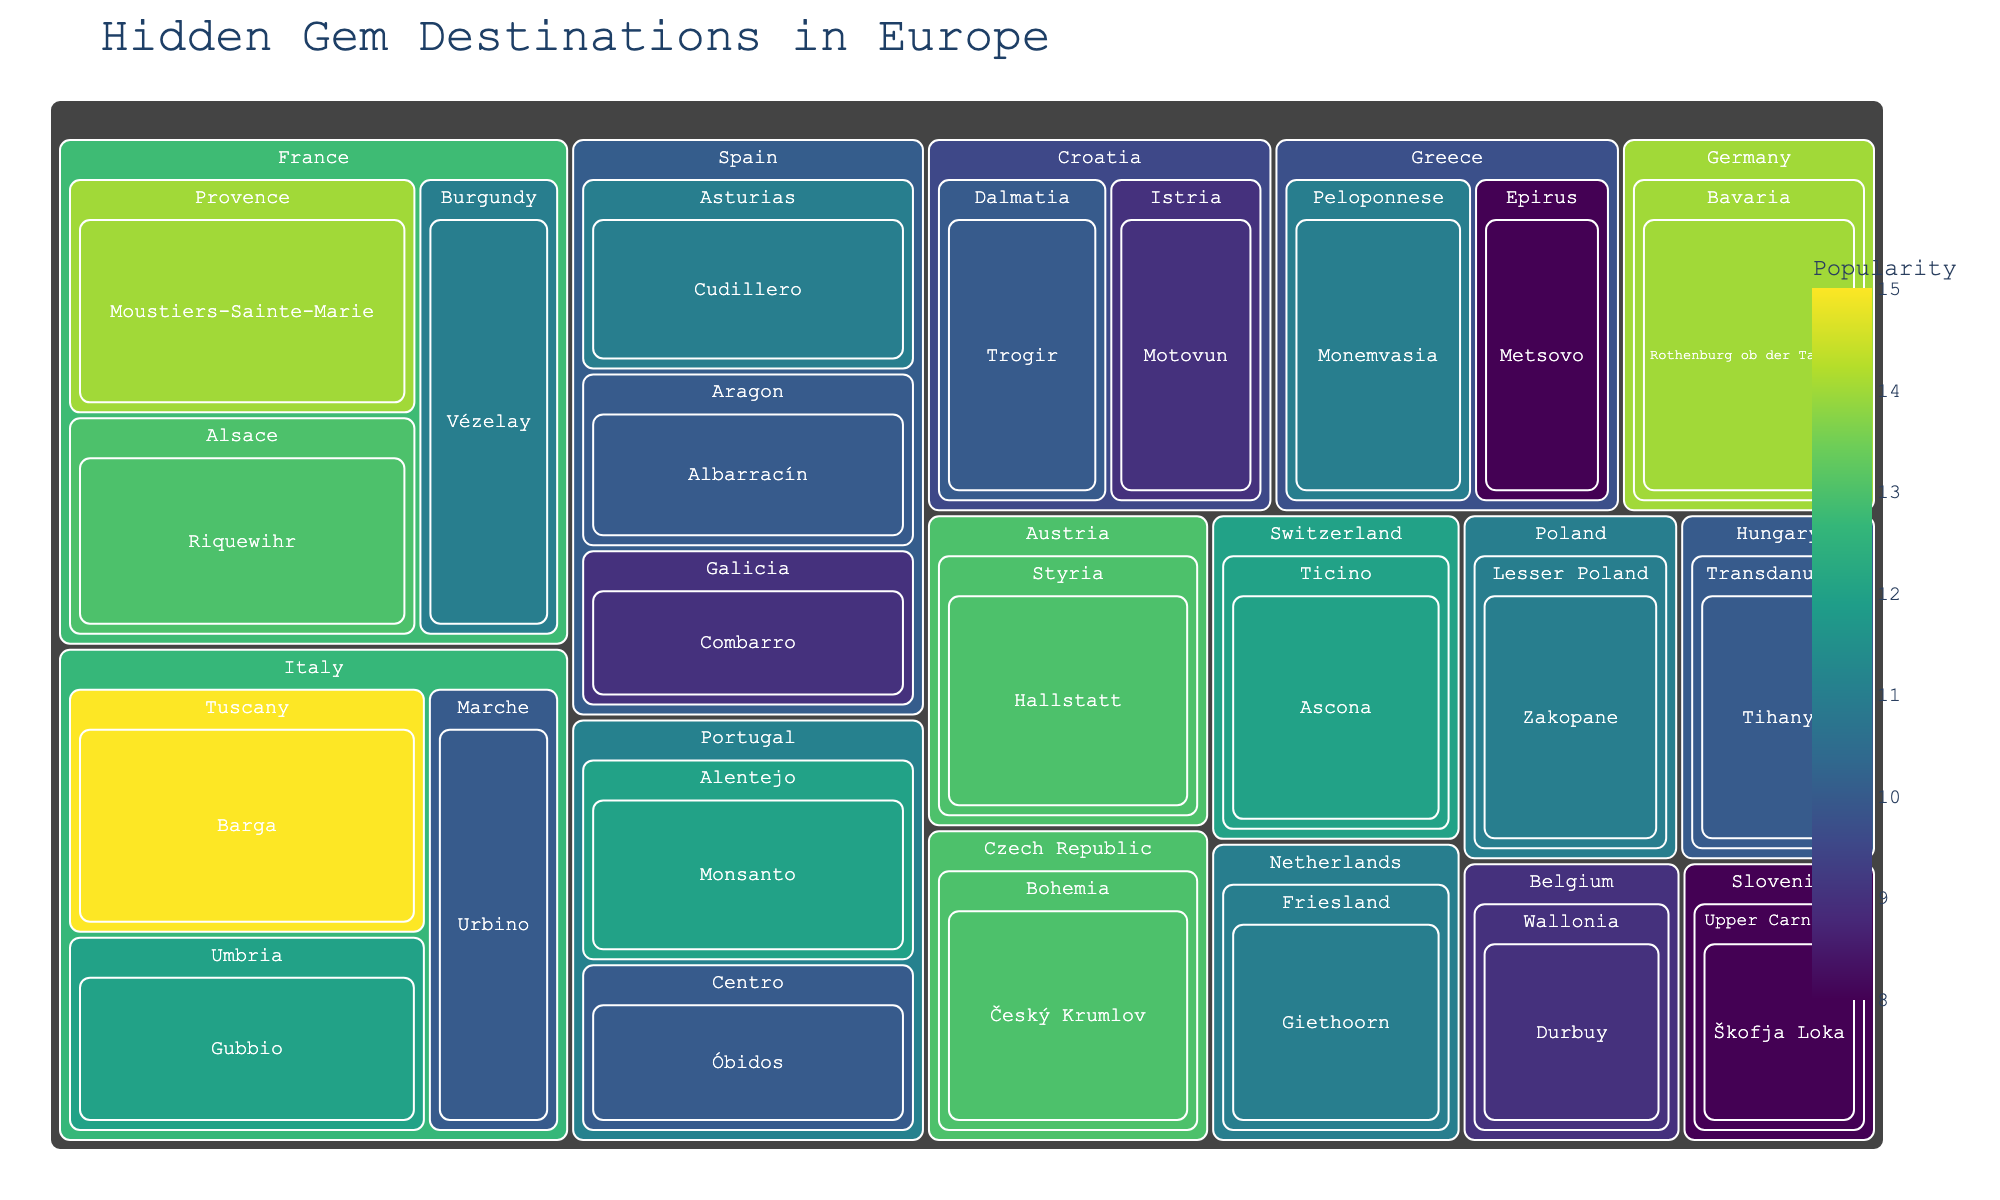What is the most popular hidden gem destination in Europe? The most popular hidden gem destination is the one with the highest value. By looking at the color intensity and the "Popularity" values, the darkest section and highest value are for Barga in Tuscany, Italy with a value of 15.
Answer: Barga Which country has the highest number of hidden gem destinations represented in the treemap? Count the unique destinations for each country. According to the data, Italy has the highest count with three destinations: Barga, Gubbio, and Urbino.
Answer: Italy How does the popularity of Hallstatt compare to that of Rothenburg ob der Tauber? Find the popularity values of both destinations. Hallstatt has a value of 13 and Rothenburg ob der Tauber has a value of 14. Rothenburg ob der Tauber is slightly more popular than Hallstatt.
Answer: Rothenburg ob der Tauber is more popular Which region in Spain has the most popular hidden gem destination? Look at each region within Spain and compare their destination values. Galicia (Combarro: 9), Asturias (Cudillero: 11), and Aragon (Albarracín: 10). So, Asturias has the highest value at 11 for Cudillero.
Answer: Asturias What is the total popularity value for all hidden gem destinations in Greece? Sum the popularity values for Metsovo (8) and Monemvasia (11). The total is 8 + 11 = 19.
Answer: 19 What is the least popular hidden gem destination in Europe? The least popular destination is the one with the lowest value. By checking the value in the treemap, Metsovo in Epirus, Greece has the lowest value of 8.
Answer: Metsovo Among France, Germany, and Switzerland, which country has a hidden gem with the highest popularity? Comparing the highest values: France (14 for Moustiers-Sainte-Marie), Germany (14 for Rothenburg ob der Tauber), Switzerland (12 for Ascona). Both France and Germany have the highest value of 14.
Answer: France and Germany What is the average popularity of hidden gems in Portugal? Find the popularity values of Monsanto (12) and Óbidos (10) in Portugal. Calculate the average (12 + 10) / 2 = 11.
Answer: 11 How many destinations have a popularity value greater than 12? Identify all destinations with values greater than 12. They are Barga (15), Moustiers-Sainte-Marie (14), Rothenburg ob der Tauber (14), Riquewihr (13), Český Krumlov (13), and Hallstatt (13). There are 6 such destinations.
Answer: 6 What is the combined popularity value of destinations in Upper Carniola, Bohemia, and Transdanubia regions? Sum the values in each region: Upper Carniola (Škofja Loka: 8), Bohemia (Český Krumlov: 13), and Transdanubia (Tihany: 10). The total is 8 + 13 + 10 = 31.
Answer: 31 